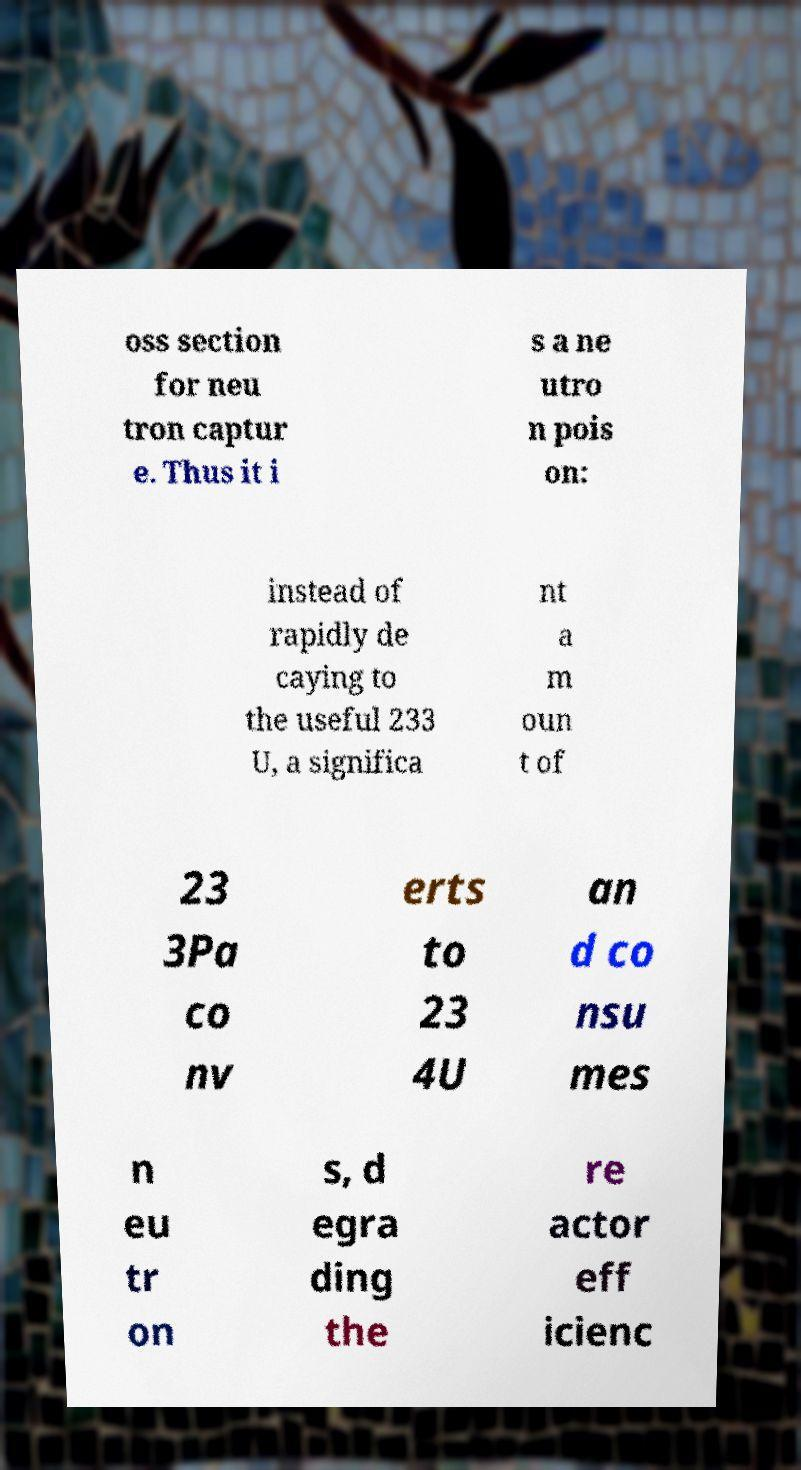There's text embedded in this image that I need extracted. Can you transcribe it verbatim? oss section for neu tron captur e. Thus it i s a ne utro n pois on: instead of rapidly de caying to the useful 233 U, a significa nt a m oun t of 23 3Pa co nv erts to 23 4U an d co nsu mes n eu tr on s, d egra ding the re actor eff icienc 